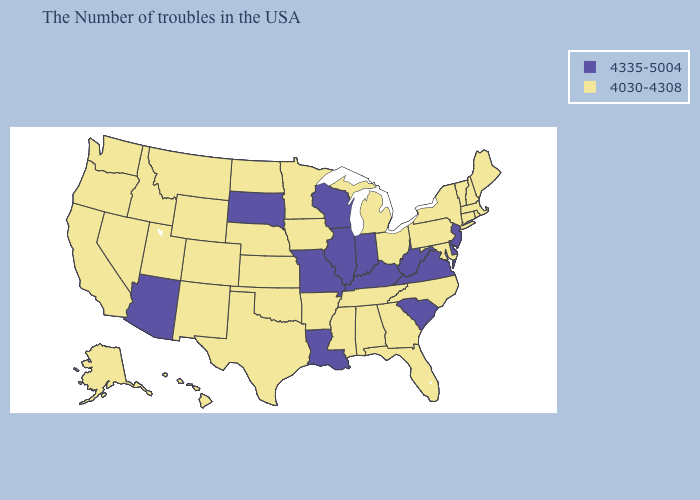Does West Virginia have a lower value than Arkansas?
Keep it brief. No. What is the highest value in the MidWest ?
Be succinct. 4335-5004. What is the value of Texas?
Be succinct. 4030-4308. What is the lowest value in the USA?
Quick response, please. 4030-4308. Does the first symbol in the legend represent the smallest category?
Quick response, please. No. Among the states that border Nevada , which have the highest value?
Write a very short answer. Arizona. What is the value of Montana?
Short answer required. 4030-4308. What is the value of Washington?
Answer briefly. 4030-4308. Among the states that border Michigan , does Ohio have the highest value?
Write a very short answer. No. What is the value of Pennsylvania?
Answer briefly. 4030-4308. What is the value of Michigan?
Give a very brief answer. 4030-4308. Does New York have the lowest value in the Northeast?
Quick response, please. Yes. Among the states that border Kentucky , does Missouri have the lowest value?
Concise answer only. No. How many symbols are there in the legend?
Concise answer only. 2. 